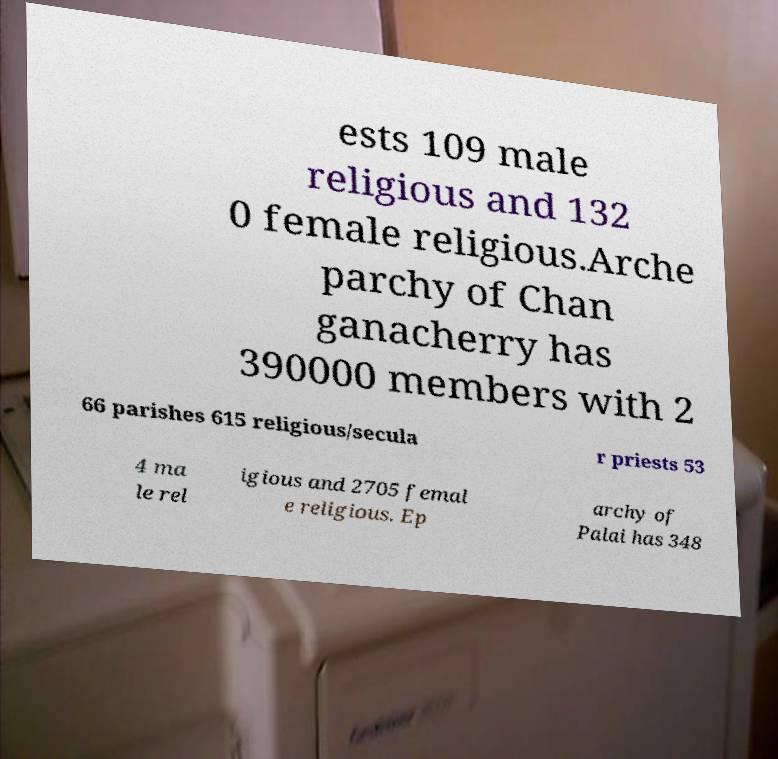Can you read and provide the text displayed in the image?This photo seems to have some interesting text. Can you extract and type it out for me? ests 109 male religious and 132 0 female religious.Arche parchy of Chan ganacherry has 390000 members with 2 66 parishes 615 religious/secula r priests 53 4 ma le rel igious and 2705 femal e religious. Ep archy of Palai has 348 